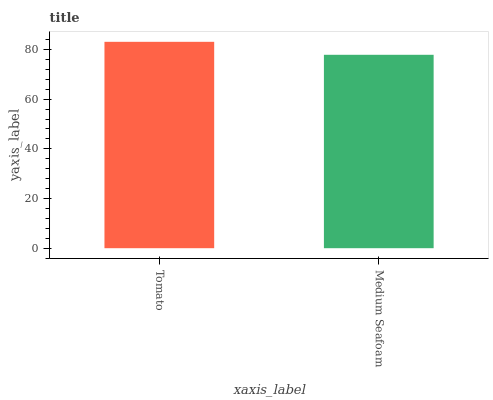Is Medium Seafoam the minimum?
Answer yes or no. Yes. Is Tomato the maximum?
Answer yes or no. Yes. Is Medium Seafoam the maximum?
Answer yes or no. No. Is Tomato greater than Medium Seafoam?
Answer yes or no. Yes. Is Medium Seafoam less than Tomato?
Answer yes or no. Yes. Is Medium Seafoam greater than Tomato?
Answer yes or no. No. Is Tomato less than Medium Seafoam?
Answer yes or no. No. Is Tomato the high median?
Answer yes or no. Yes. Is Medium Seafoam the low median?
Answer yes or no. Yes. Is Medium Seafoam the high median?
Answer yes or no. No. Is Tomato the low median?
Answer yes or no. No. 